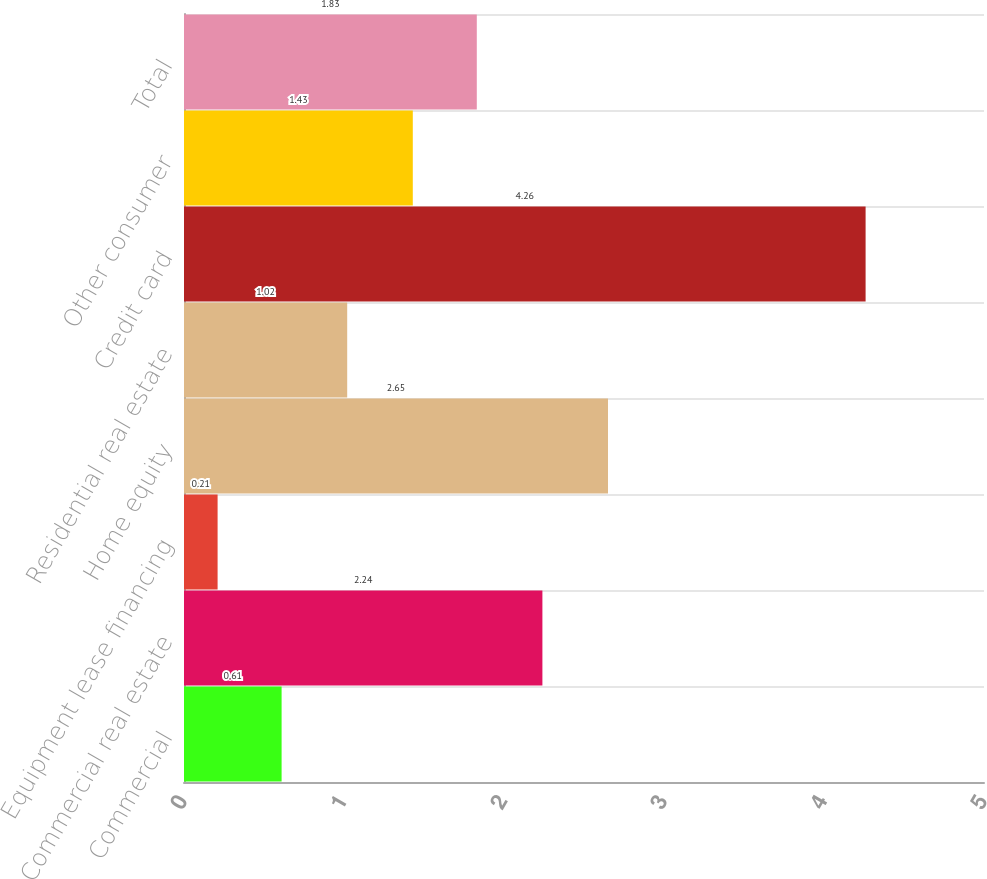<chart> <loc_0><loc_0><loc_500><loc_500><bar_chart><fcel>Commercial<fcel>Commercial real estate<fcel>Equipment lease financing<fcel>Home equity<fcel>Residential real estate<fcel>Credit card<fcel>Other consumer<fcel>Total<nl><fcel>0.61<fcel>2.24<fcel>0.21<fcel>2.65<fcel>1.02<fcel>4.26<fcel>1.43<fcel>1.83<nl></chart> 